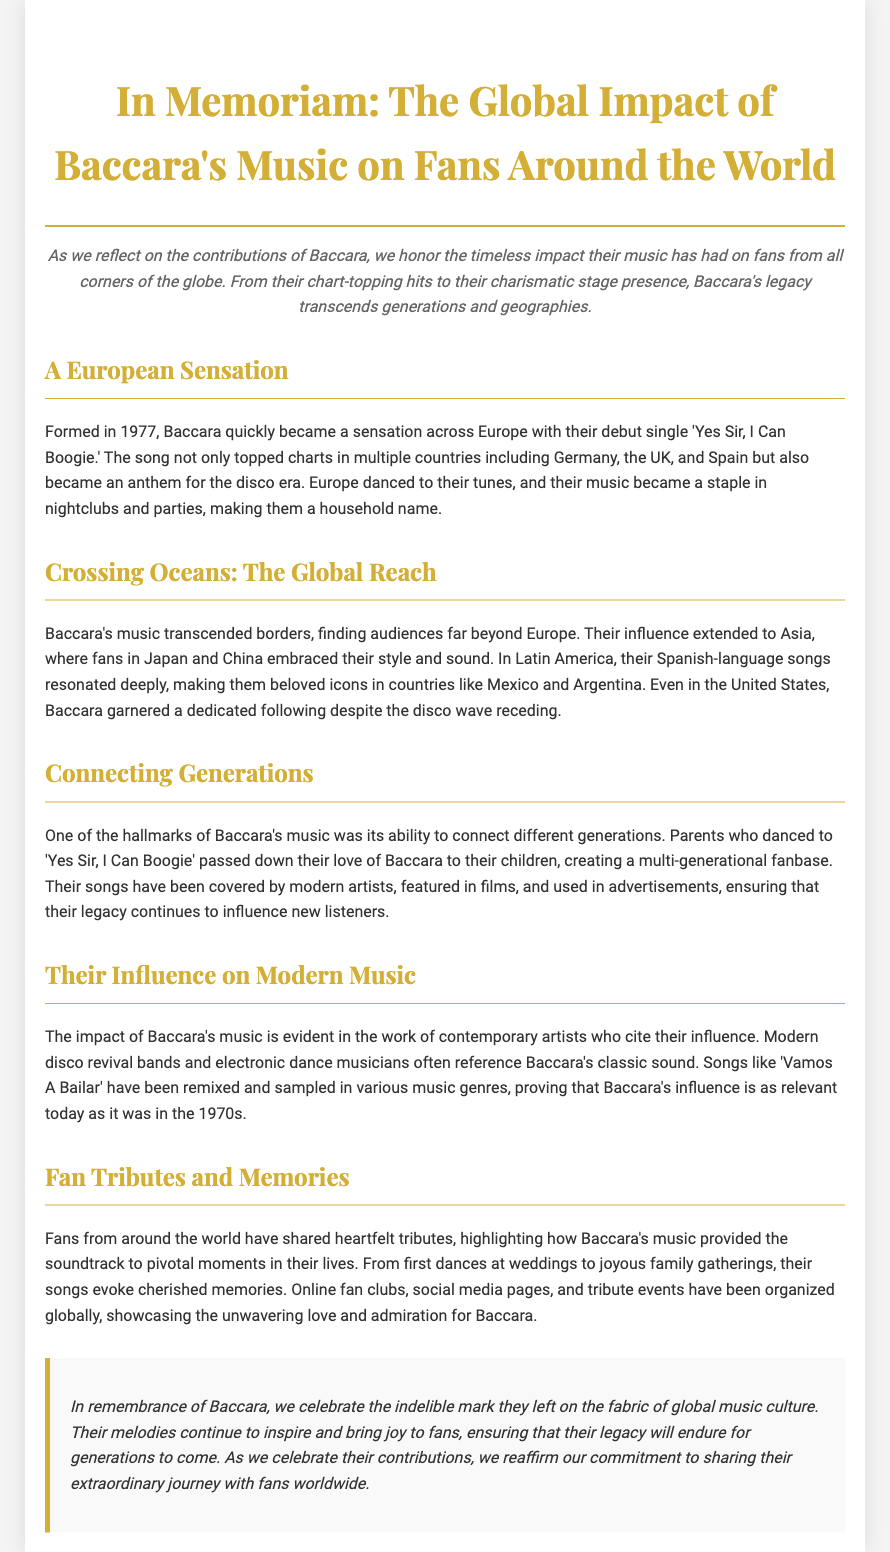What year was Baccara formed? Baccara was formed in 1977, as mentioned in their history in the document.
Answer: 1977 What is the title of Baccara's debut single? The document states that their debut single is 'Yes Sir, I Can Boogie.'
Answer: 'Yes Sir, I Can Boogie' In which countries did 'Yes Sir, I Can Boogie' top charts? The document lists Germany, the UK, and Spain as countries where the song topped the charts.
Answer: Germany, the UK, and Spain Which regions embraced Baccara's music outside of Europe? The document mentions Asia and Latin America as regions that embraced Baccara's music.
Answer: Asia and Latin America What is a hallmark of Baccara's music according to the document? The document states that connecting different generations is a hallmark of Baccara's music.
Answer: Connecting different generations How have modern artists interacted with Baccara's songs? The document mentions that modern artists have covered their songs and referenced their influence.
Answer: Covered their songs and referenced their influence What phrase describes the global impact of Baccara's music in the conclusion? The conclusion describes their impact as an "indelible mark on the fabric of global music culture."
Answer: Indelible mark on the fabric of global music culture What kind of events have fans organized in tribute to Baccara? The document mentions online fan clubs, social media pages, and tribute events organized globally.
Answer: Online fan clubs, social media pages, and tribute events What is the tone of the conclusion regarding Baccara's legacy? The conclusion's tone emphasizes celebration and commitment to sharing Baccara's extraordinary journey.
Answer: Celebration and commitment to sharing Baccara's extraordinary journey 